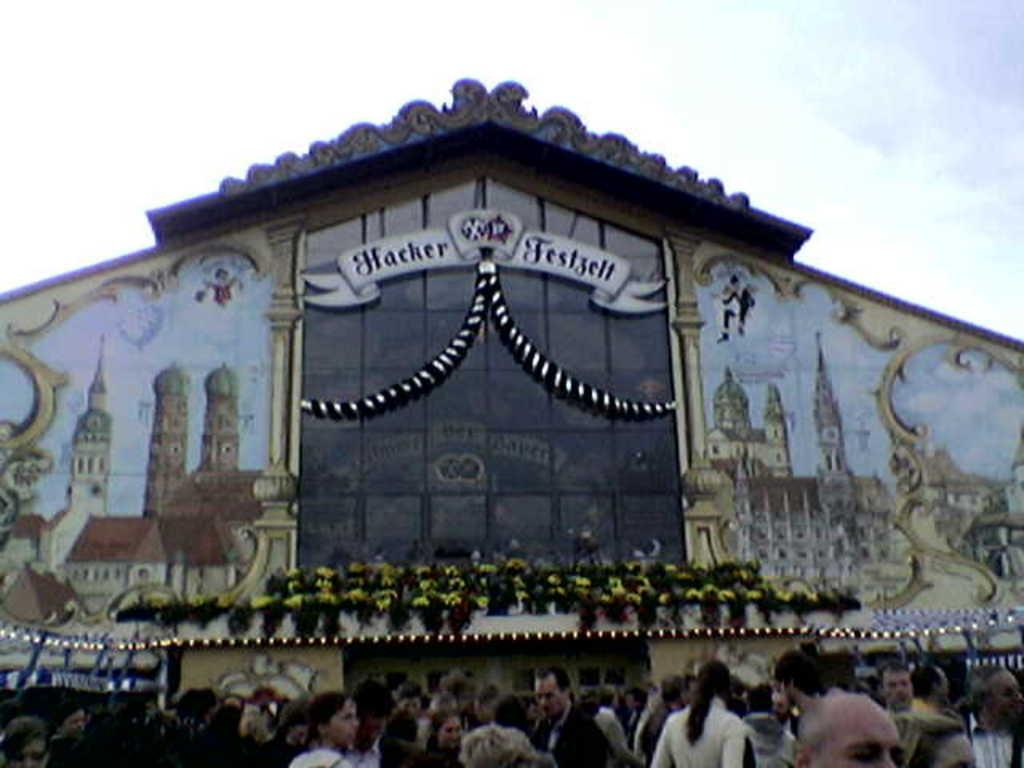Provide a one-sentence caption for the provided image. A Hacker Festival sign hangs in front of a large set of windows on a building. 